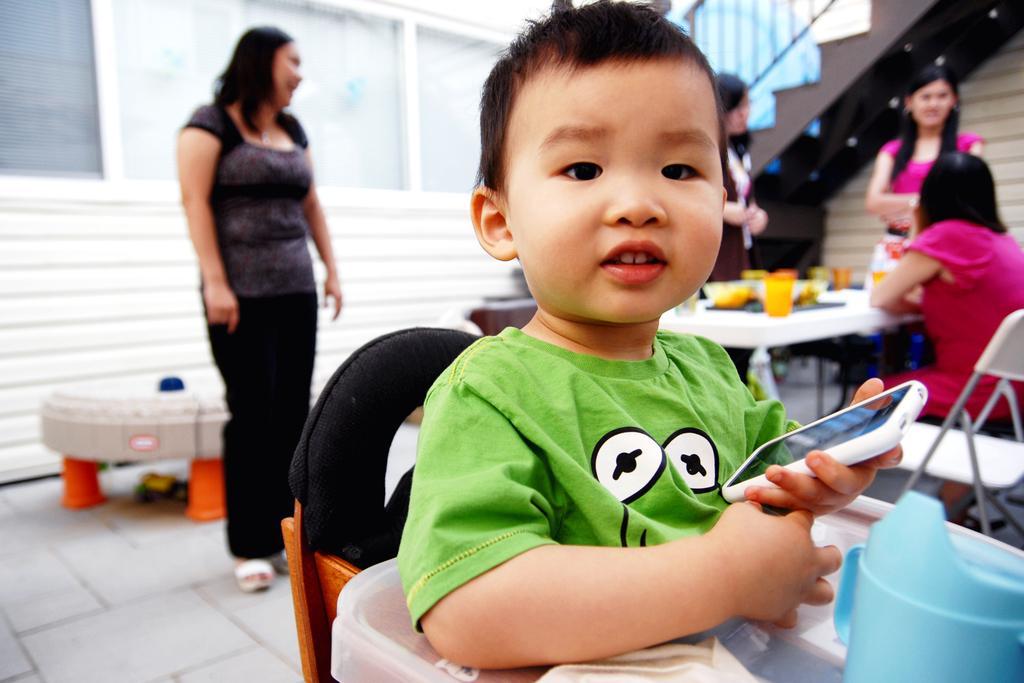How would you summarize this image in a sentence or two? This picture does a woman standing and there is a boy, holding a smartphone with his hand and smiling 